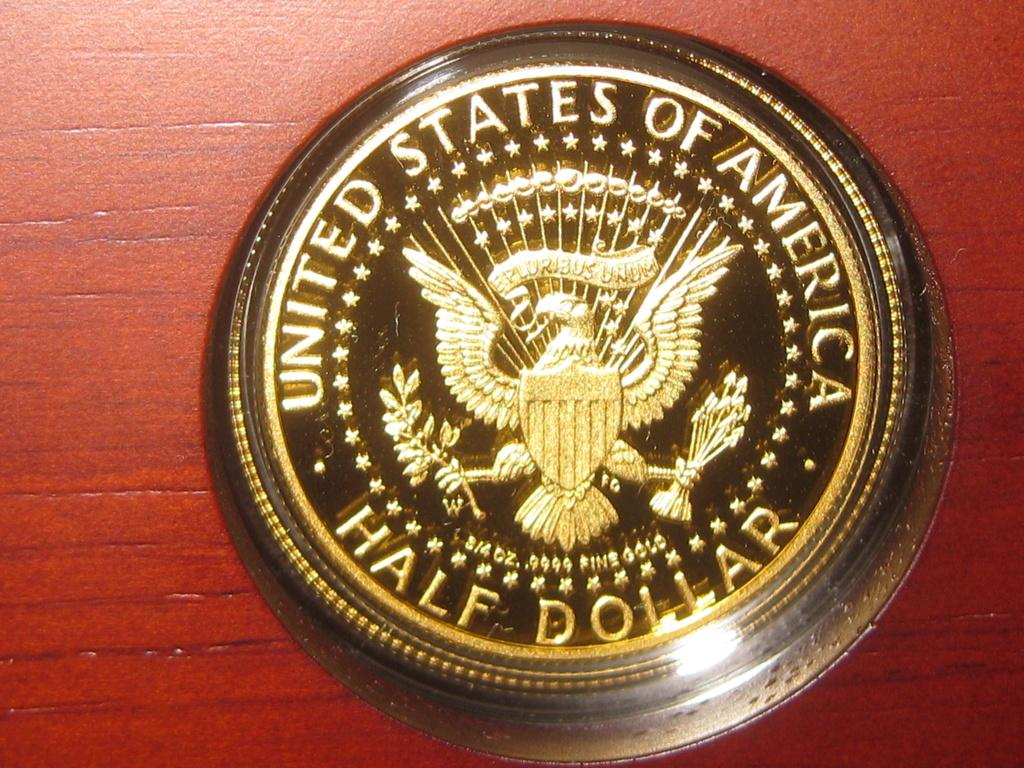<image>
Provide a brief description of the given image. Gold round half dollar coin behind a plastic case. 